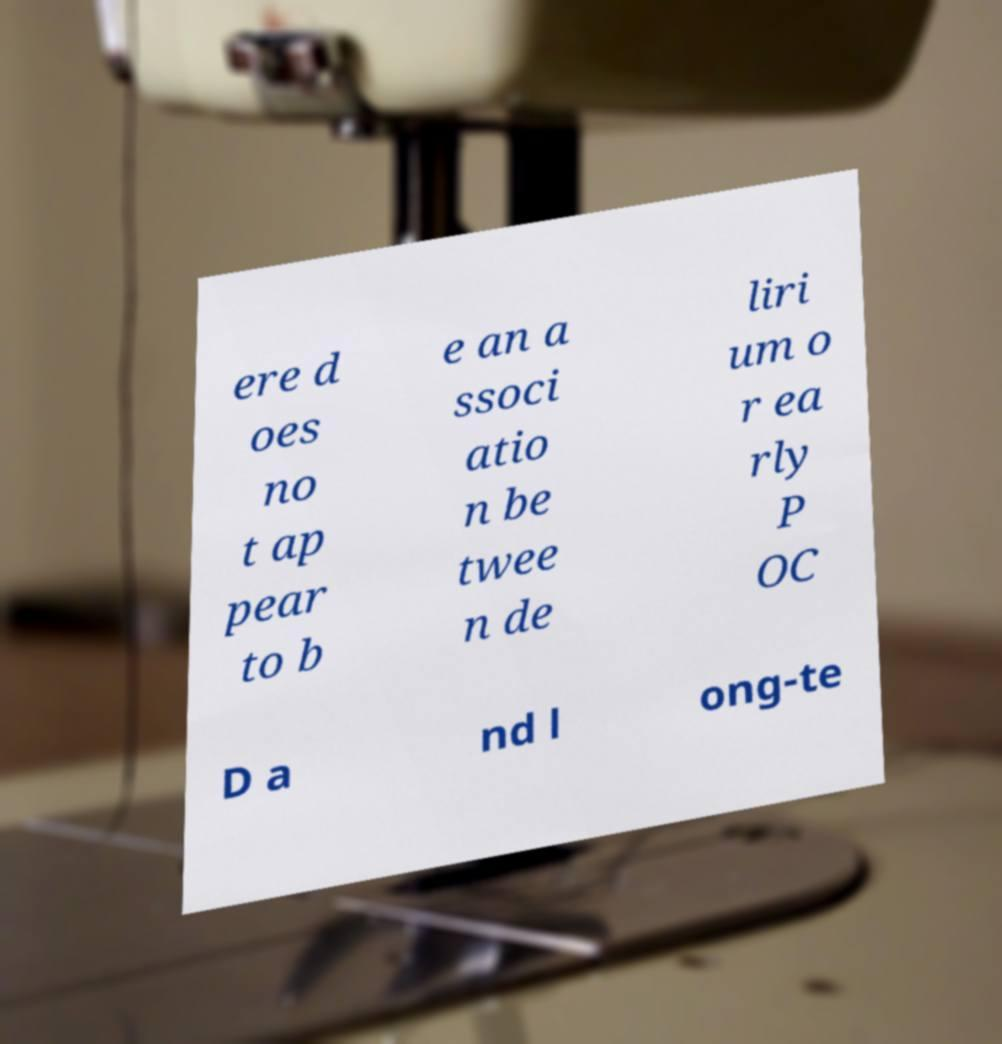What messages or text are displayed in this image? I need them in a readable, typed format. ere d oes no t ap pear to b e an a ssoci atio n be twee n de liri um o r ea rly P OC D a nd l ong-te 